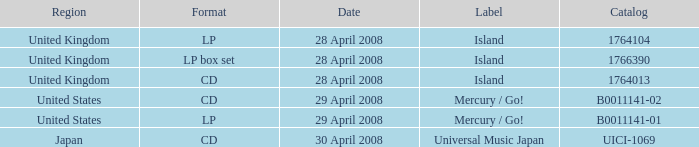What is the Label of the UICI-1069 Catalog? Universal Music Japan. 